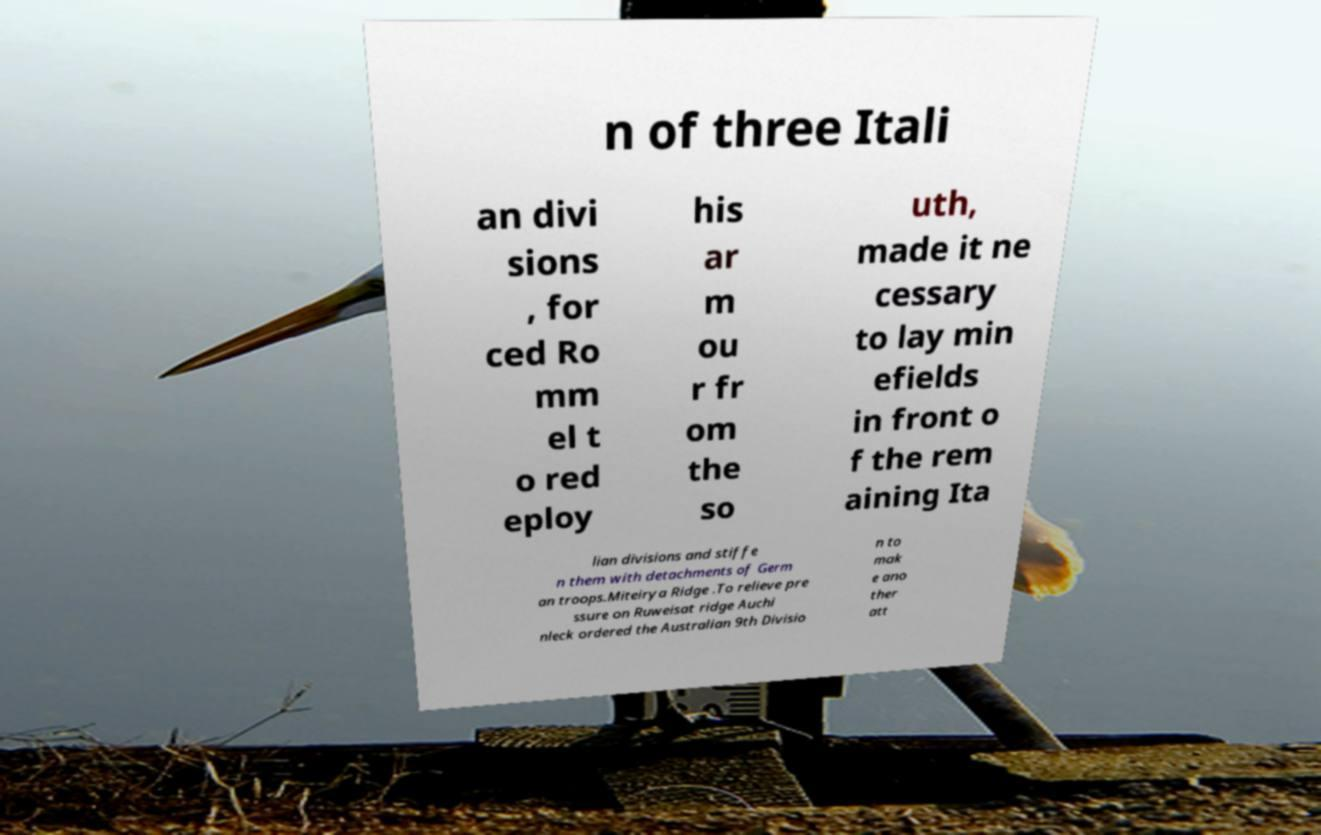Could you extract and type out the text from this image? n of three Itali an divi sions , for ced Ro mm el t o red eploy his ar m ou r fr om the so uth, made it ne cessary to lay min efields in front o f the rem aining Ita lian divisions and stiffe n them with detachments of Germ an troops.Miteirya Ridge .To relieve pre ssure on Ruweisat ridge Auchi nleck ordered the Australian 9th Divisio n to mak e ano ther att 